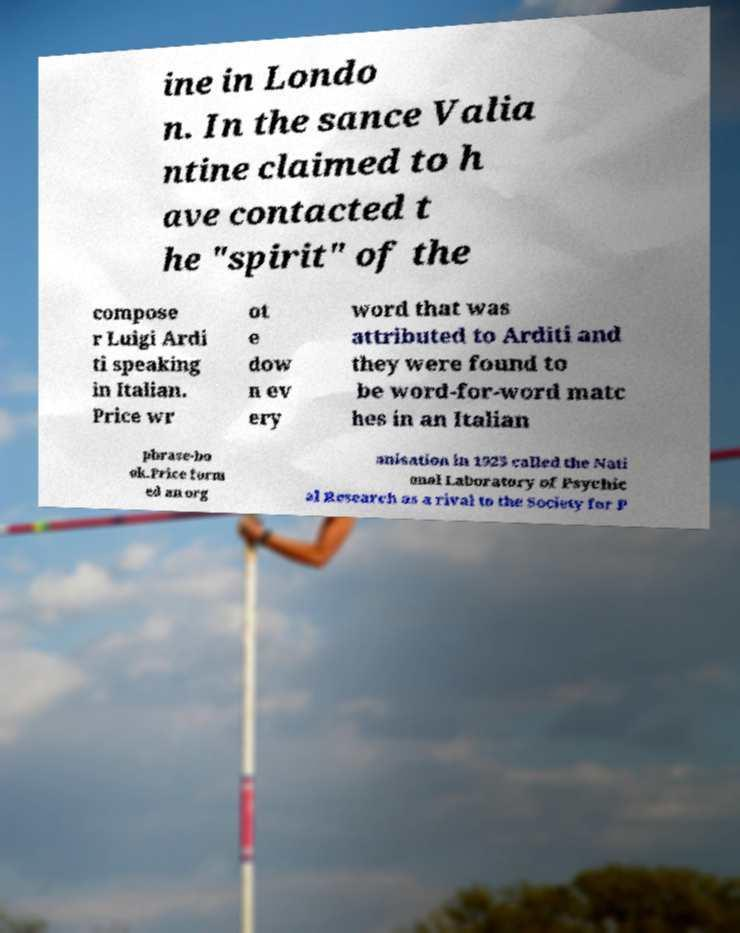Can you accurately transcribe the text from the provided image for me? ine in Londo n. In the sance Valia ntine claimed to h ave contacted t he "spirit" of the compose r Luigi Ardi ti speaking in Italian. Price wr ot e dow n ev ery word that was attributed to Arditi and they were found to be word-for-word matc hes in an Italian phrase-bo ok.Price form ed an org anisation in 1925 called the Nati onal Laboratory of Psychic al Research as a rival to the Society for P 